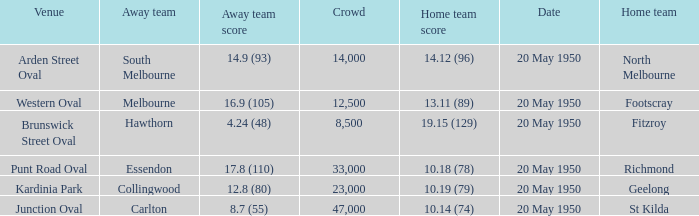What was the score for the away team that played against Richmond and has a crowd over 12,500? 17.8 (110). 